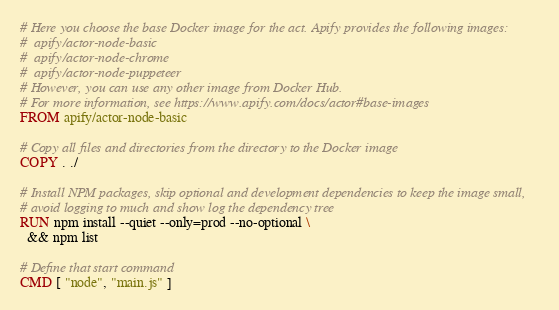<code> <loc_0><loc_0><loc_500><loc_500><_Dockerfile_>
# Here you choose the base Docker image for the act. Apify provides the following images:
#  apify/actor-node-basic
#  apify/actor-node-chrome
#  apify/actor-node-puppeteer
# However, you can use any other image from Docker Hub.
# For more information, see https://www.apify.com/docs/actor#base-images
FROM apify/actor-node-basic

# Copy all files and directories from the directory to the Docker image
COPY . ./

# Install NPM packages, skip optional and development dependencies to keep the image small,
# avoid logging to much and show log the dependency tree
RUN npm install --quiet --only=prod --no-optional \
  && npm list

# Define that start command
CMD [ "node", "main.js" ]
</code> 